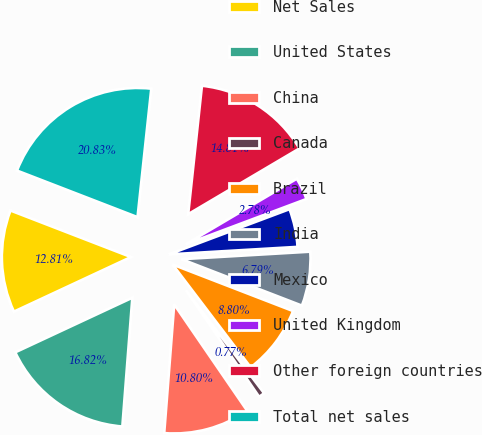<chart> <loc_0><loc_0><loc_500><loc_500><pie_chart><fcel>Net Sales<fcel>United States<fcel>China<fcel>Canada<fcel>Brazil<fcel>India<fcel>Mexico<fcel>United Kingdom<fcel>Other foreign countries<fcel>Total net sales<nl><fcel>12.81%<fcel>16.82%<fcel>10.8%<fcel>0.77%<fcel>8.8%<fcel>6.79%<fcel>4.78%<fcel>2.78%<fcel>14.81%<fcel>20.83%<nl></chart> 